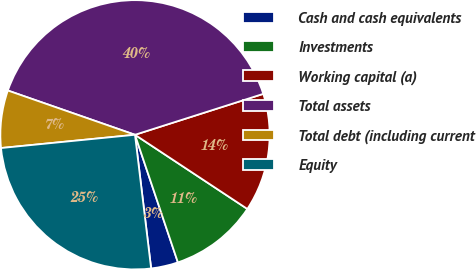<chart> <loc_0><loc_0><loc_500><loc_500><pie_chart><fcel>Cash and cash equivalents<fcel>Investments<fcel>Working capital (a)<fcel>Total assets<fcel>Total debt (including current<fcel>Equity<nl><fcel>3.25%<fcel>10.55%<fcel>14.2%<fcel>39.75%<fcel>6.9%<fcel>25.34%<nl></chart> 